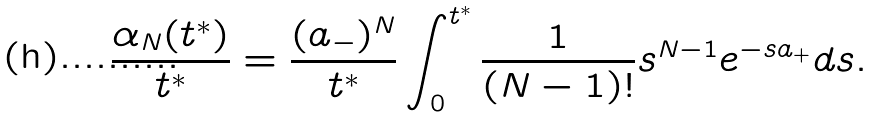Convert formula to latex. <formula><loc_0><loc_0><loc_500><loc_500>\frac { \alpha _ { N } ( t ^ { * } ) } { t ^ { * } } = \frac { ( a _ { - } ) ^ { N } } { t ^ { * } } \int _ { 0 } ^ { t ^ { * } } \frac { 1 } { ( N - 1 ) ! } s ^ { N - 1 } e ^ { - s a _ { + } } d s .</formula> 